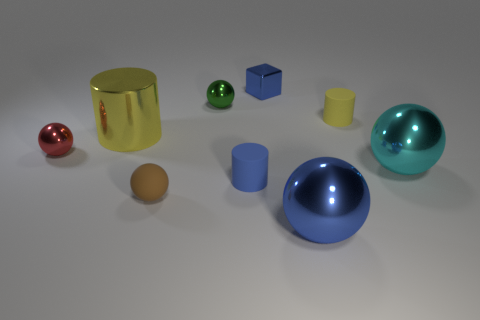Are there fewer small shiny spheres that are on the right side of the green sphere than small objects that are in front of the small yellow rubber cylinder?
Make the answer very short. Yes. There is a tiny object that is left of the small block and behind the red shiny object; what material is it?
Ensure brevity in your answer.  Metal. There is a yellow thing that is in front of the matte object behind the big cyan thing; what is its shape?
Your answer should be compact. Cylinder. What number of cyan things are either metal cubes or cylinders?
Offer a terse response. 0. Are there any tiny blue rubber objects behind the tiny blue rubber cylinder?
Provide a short and direct response. No. The blue metallic cube is what size?
Give a very brief answer. Small. What is the size of the yellow matte thing that is the same shape as the blue matte object?
Your answer should be very brief. Small. What number of blue metallic objects are to the left of the big metal object in front of the tiny brown ball?
Offer a terse response. 1. Do the blue object in front of the blue cylinder and the yellow object to the left of the blue metallic block have the same material?
Your answer should be compact. Yes. How many big cyan metal objects have the same shape as the small red object?
Make the answer very short. 1. 